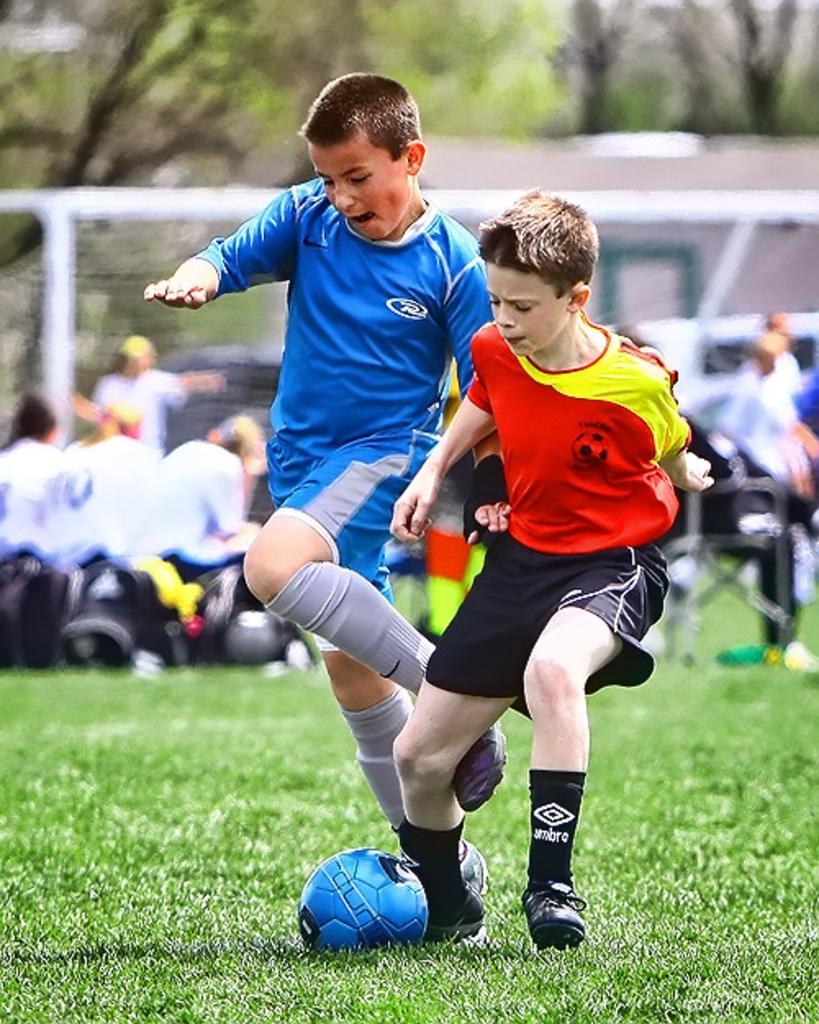Can you describe this image briefly? In this see image I can see two boys and a football on this ground. In the background I can see few more people and few trees. 